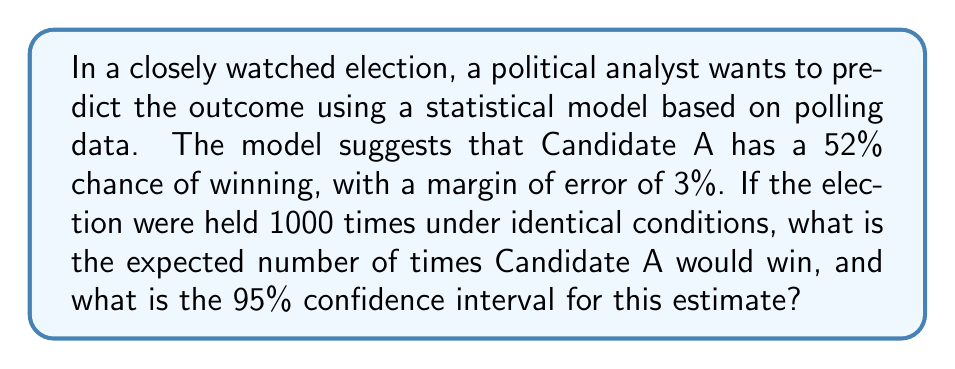Teach me how to tackle this problem. To solve this problem, we'll follow these steps:

1. Calculate the expected number of wins:
   The expected number of wins is simply the probability of winning multiplied by the number of trials.
   
   Expected wins = $0.52 \times 1000 = 520$

2. Calculate the standard error:
   The standard error for a binomial distribution is given by:
   
   $SE = \sqrt{np(1-p)}$
   
   Where $n$ is the number of trials, and $p$ is the probability of success.
   
   $SE = \sqrt{1000 \times 0.52 \times (1-0.52)} = \sqrt{249.6} \approx 15.8$

3. Calculate the 95% confidence interval:
   For a 95% confidence interval, we use 1.96 standard deviations from the mean.
   
   Lower bound = $520 - (1.96 \times 15.8) \approx 489$
   Upper bound = $520 + (1.96 \times 15.8) \approx 551$

Therefore, we can expect Candidate A to win 520 times out of 1000 elections, with a 95% confidence interval of approximately 489 to 551 wins.
Answer: 520 wins; 95% CI: [489, 551] 